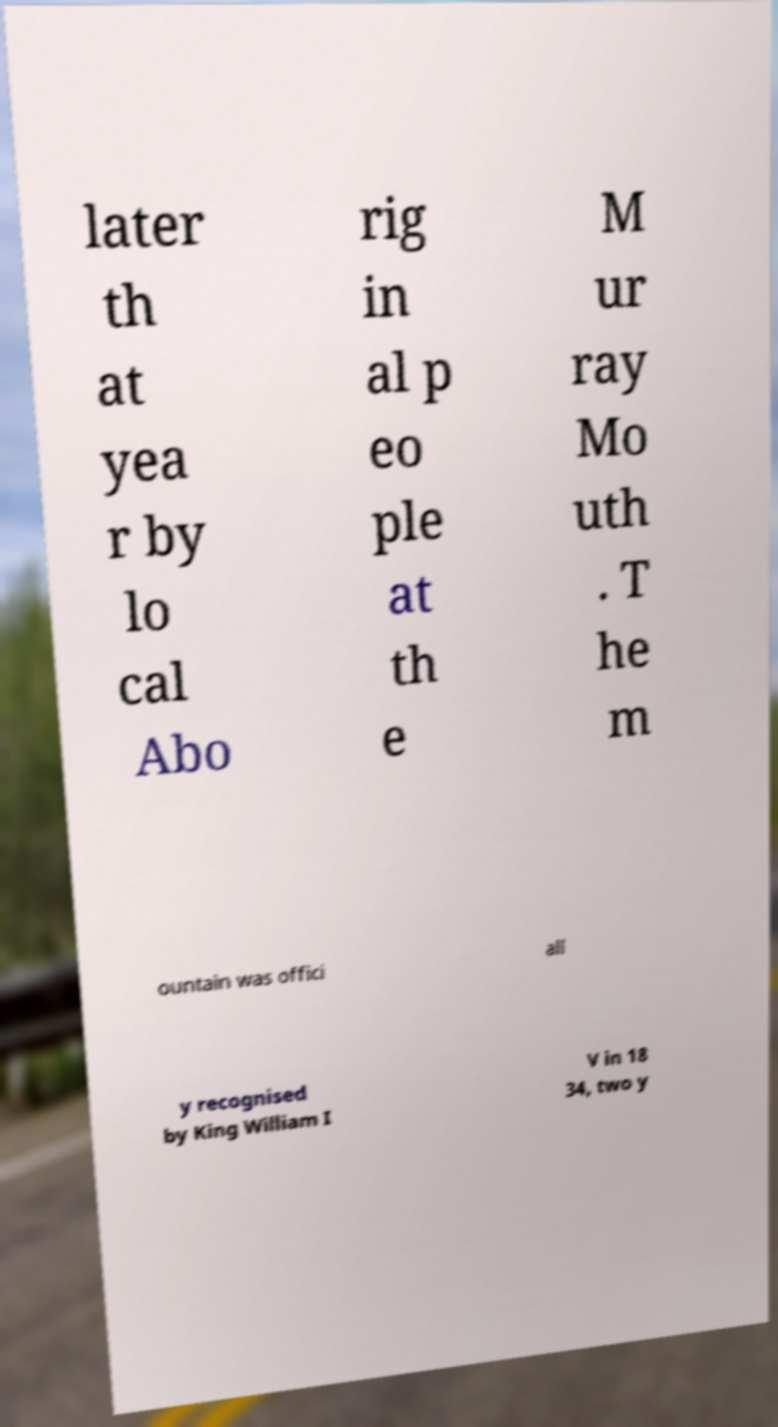What messages or text are displayed in this image? I need them in a readable, typed format. later th at yea r by lo cal Abo rig in al p eo ple at th e M ur ray Mo uth . T he m ountain was offici all y recognised by King William I V in 18 34, two y 